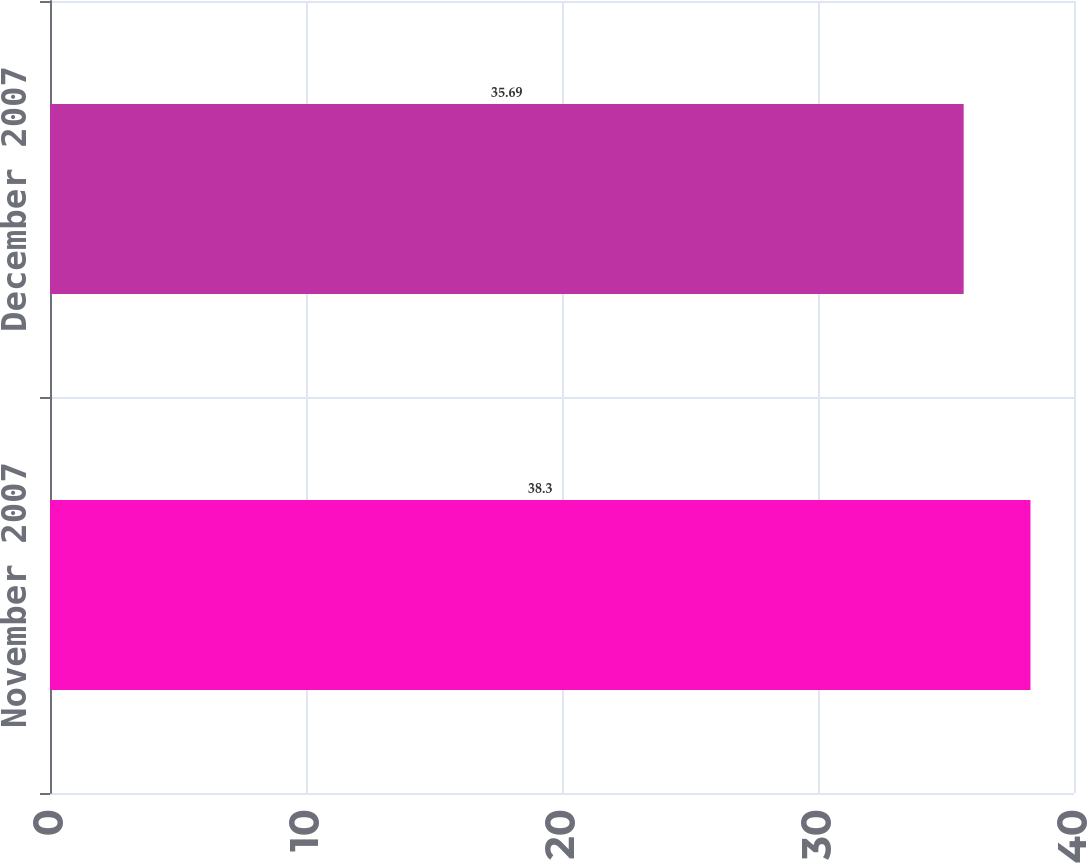Convert chart. <chart><loc_0><loc_0><loc_500><loc_500><bar_chart><fcel>November 2007<fcel>December 2007<nl><fcel>38.3<fcel>35.69<nl></chart> 